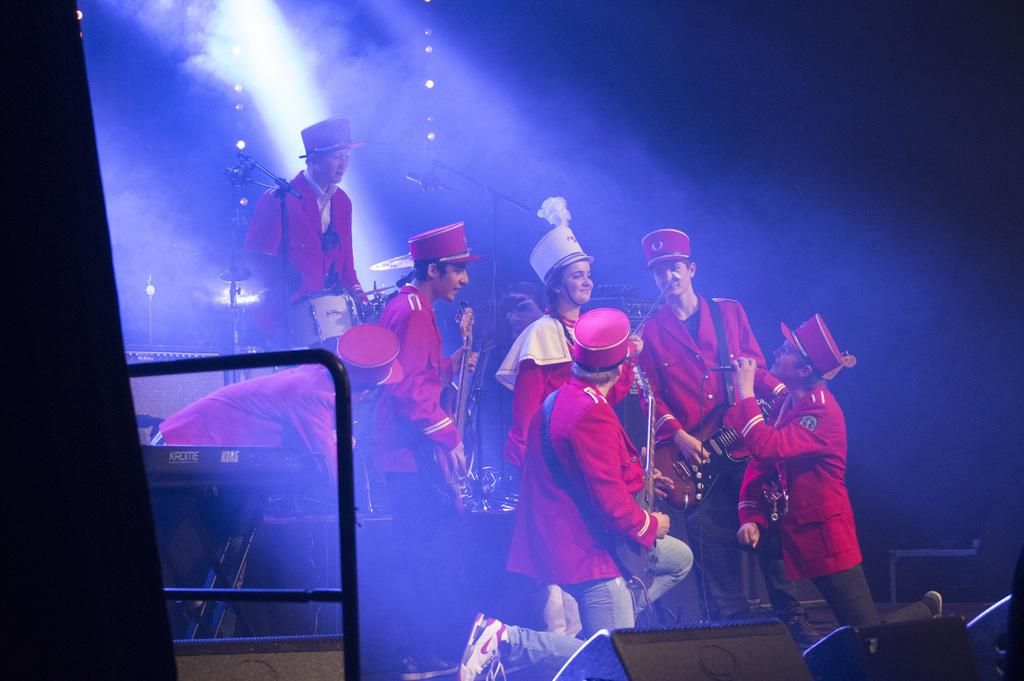How many people are in the image? There is a group of people in the image. What are the people wearing on their heads? The people are wearing caps. What are the people doing in the image? The people are playing musical instruments, including guitars and drums. What can be seen in the background of the image? There are lights visible in the background of the image. What is the lighting condition in the image? The image appears to be set in a dark environment. What type of page is being turned in the image? There is no page being turned in the image; it features a group of people playing musical instruments. Is there a carriage visible in the image? No, there is no carriage present in the image. 